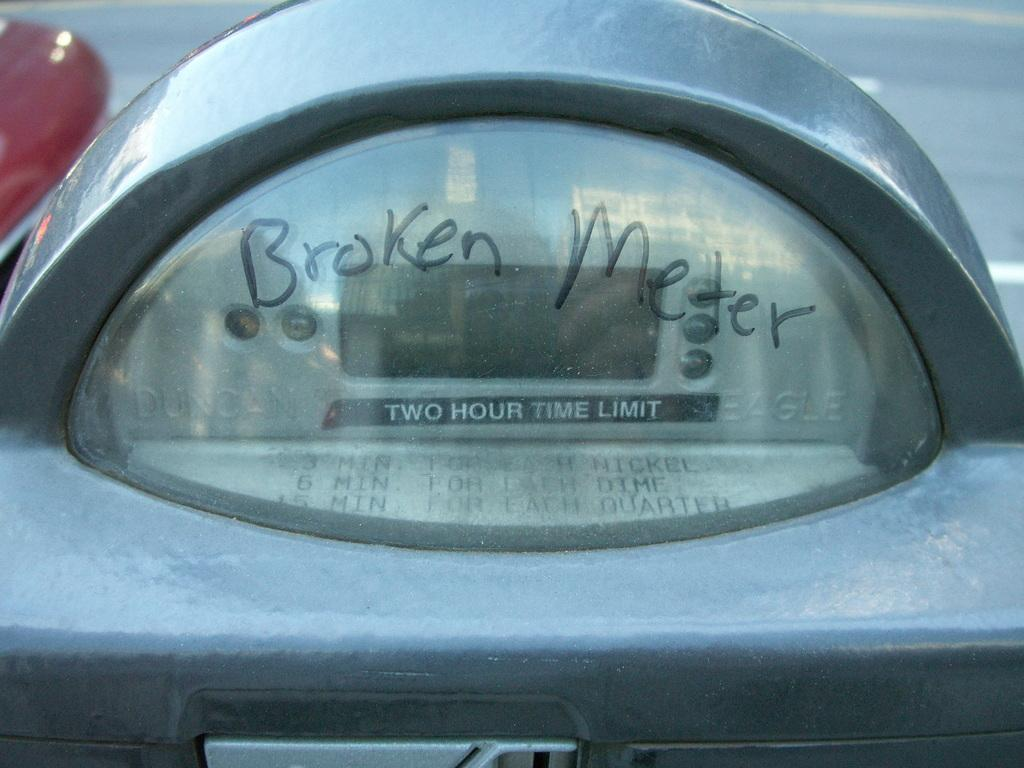<image>
Create a compact narrative representing the image presented. A meter on the side of the road reads Borken Meter 